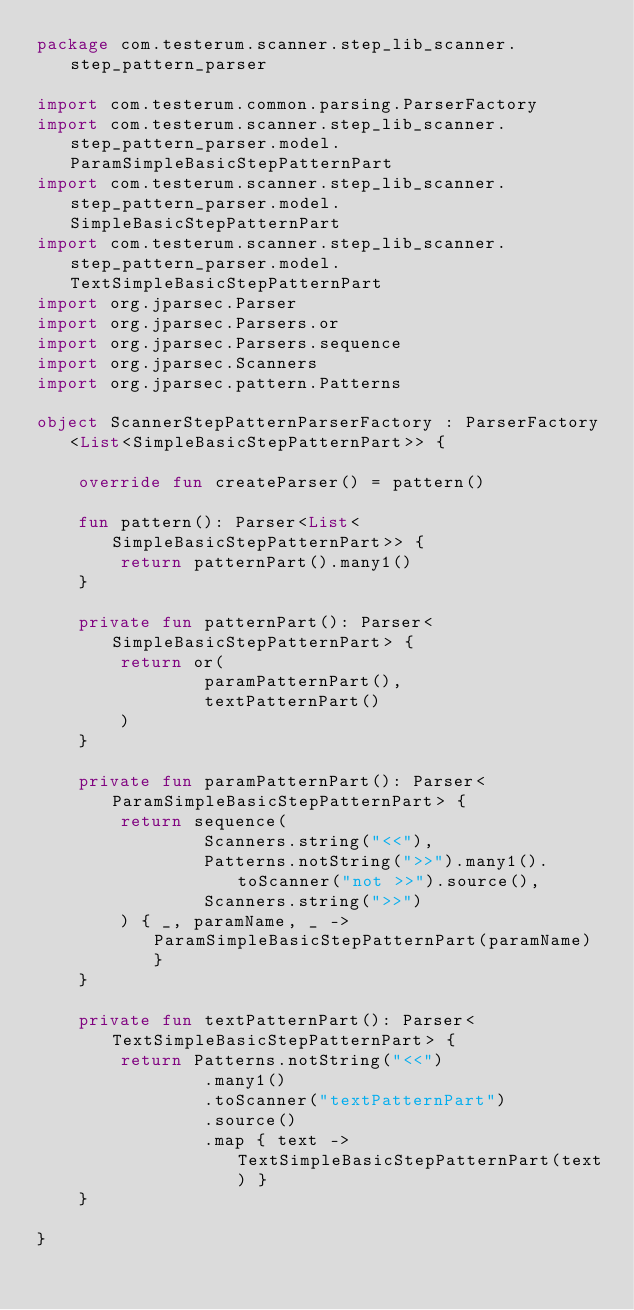<code> <loc_0><loc_0><loc_500><loc_500><_Kotlin_>package com.testerum.scanner.step_lib_scanner.step_pattern_parser

import com.testerum.common.parsing.ParserFactory
import com.testerum.scanner.step_lib_scanner.step_pattern_parser.model.ParamSimpleBasicStepPatternPart
import com.testerum.scanner.step_lib_scanner.step_pattern_parser.model.SimpleBasicStepPatternPart
import com.testerum.scanner.step_lib_scanner.step_pattern_parser.model.TextSimpleBasicStepPatternPart
import org.jparsec.Parser
import org.jparsec.Parsers.or
import org.jparsec.Parsers.sequence
import org.jparsec.Scanners
import org.jparsec.pattern.Patterns

object ScannerStepPatternParserFactory : ParserFactory<List<SimpleBasicStepPatternPart>> {

    override fun createParser() = pattern()

    fun pattern(): Parser<List<SimpleBasicStepPatternPart>> {
        return patternPart().many1()
    }

    private fun patternPart(): Parser<SimpleBasicStepPatternPart> {
        return or(
                paramPatternPart(),
                textPatternPart()
        )
    }

    private fun paramPatternPart(): Parser<ParamSimpleBasicStepPatternPart> {
        return sequence(
                Scanners.string("<<"),
                Patterns.notString(">>").many1().toScanner("not >>").source(),
                Scanners.string(">>")
        ) { _, paramName, _ -> ParamSimpleBasicStepPatternPart(paramName) }
    }

    private fun textPatternPart(): Parser<TextSimpleBasicStepPatternPart> {
        return Patterns.notString("<<")
                .many1()
                .toScanner("textPatternPart")
                .source()
                .map { text -> TextSimpleBasicStepPatternPart(text) }
    }

}</code> 